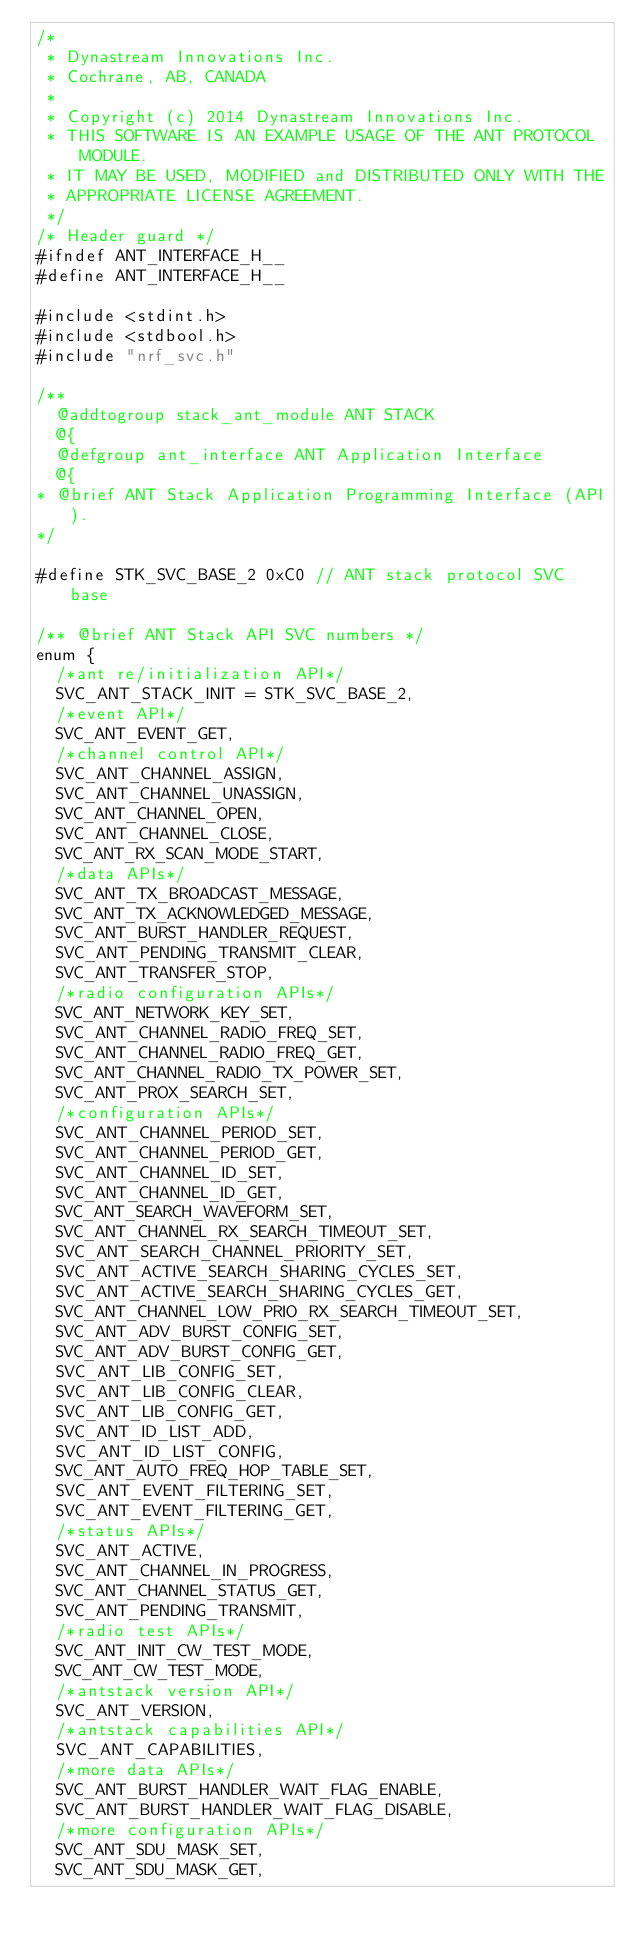Convert code to text. <code><loc_0><loc_0><loc_500><loc_500><_C_>/*
 * Dynastream Innovations Inc.
 * Cochrane, AB, CANADA
 *
 * Copyright (c) 2014 Dynastream Innovations Inc.
 * THIS SOFTWARE IS AN EXAMPLE USAGE OF THE ANT PROTOCOL MODULE.
 * IT MAY BE USED, MODIFIED and DISTRIBUTED ONLY WITH THE
 * APPROPRIATE LICENSE AGREEMENT.
 */
/* Header guard */
#ifndef ANT_INTERFACE_H__
#define ANT_INTERFACE_H__

#include <stdint.h>
#include <stdbool.h>
#include "nrf_svc.h"

/**
  @addtogroup stack_ant_module ANT STACK
  @{
  @defgroup ant_interface ANT Application Interface
  @{
* @brief ANT Stack Application Programming Interface (API).
*/

#define STK_SVC_BASE_2 0xC0 // ANT stack protocol SVC base

/** @brief ANT Stack API SVC numbers */
enum {
  /*ant re/initialization API*/
  SVC_ANT_STACK_INIT = STK_SVC_BASE_2,
  /*event API*/
  SVC_ANT_EVENT_GET,
  /*channel control API*/
  SVC_ANT_CHANNEL_ASSIGN,
  SVC_ANT_CHANNEL_UNASSIGN,
  SVC_ANT_CHANNEL_OPEN,
  SVC_ANT_CHANNEL_CLOSE,
  SVC_ANT_RX_SCAN_MODE_START,
  /*data APIs*/
  SVC_ANT_TX_BROADCAST_MESSAGE,
  SVC_ANT_TX_ACKNOWLEDGED_MESSAGE,
  SVC_ANT_BURST_HANDLER_REQUEST,
  SVC_ANT_PENDING_TRANSMIT_CLEAR,
  SVC_ANT_TRANSFER_STOP,
  /*radio configuration APIs*/
  SVC_ANT_NETWORK_KEY_SET,
  SVC_ANT_CHANNEL_RADIO_FREQ_SET,
  SVC_ANT_CHANNEL_RADIO_FREQ_GET,
  SVC_ANT_CHANNEL_RADIO_TX_POWER_SET,
  SVC_ANT_PROX_SEARCH_SET,
  /*configuration APIs*/
  SVC_ANT_CHANNEL_PERIOD_SET,
  SVC_ANT_CHANNEL_PERIOD_GET,
  SVC_ANT_CHANNEL_ID_SET,
  SVC_ANT_CHANNEL_ID_GET,
  SVC_ANT_SEARCH_WAVEFORM_SET,
  SVC_ANT_CHANNEL_RX_SEARCH_TIMEOUT_SET,
  SVC_ANT_SEARCH_CHANNEL_PRIORITY_SET,
  SVC_ANT_ACTIVE_SEARCH_SHARING_CYCLES_SET,
  SVC_ANT_ACTIVE_SEARCH_SHARING_CYCLES_GET,
  SVC_ANT_CHANNEL_LOW_PRIO_RX_SEARCH_TIMEOUT_SET,
  SVC_ANT_ADV_BURST_CONFIG_SET,
  SVC_ANT_ADV_BURST_CONFIG_GET,
  SVC_ANT_LIB_CONFIG_SET,
  SVC_ANT_LIB_CONFIG_CLEAR,
  SVC_ANT_LIB_CONFIG_GET,
  SVC_ANT_ID_LIST_ADD,
  SVC_ANT_ID_LIST_CONFIG,
  SVC_ANT_AUTO_FREQ_HOP_TABLE_SET,
  SVC_ANT_EVENT_FILTERING_SET,
  SVC_ANT_EVENT_FILTERING_GET,
  /*status APIs*/
  SVC_ANT_ACTIVE,
  SVC_ANT_CHANNEL_IN_PROGRESS,
  SVC_ANT_CHANNEL_STATUS_GET,
  SVC_ANT_PENDING_TRANSMIT,
  /*radio test APIs*/
  SVC_ANT_INIT_CW_TEST_MODE,
  SVC_ANT_CW_TEST_MODE,
  /*antstack version API*/
  SVC_ANT_VERSION,
  /*antstack capabilities API*/
  SVC_ANT_CAPABILITIES,
  /*more data APIs*/
  SVC_ANT_BURST_HANDLER_WAIT_FLAG_ENABLE,
  SVC_ANT_BURST_HANDLER_WAIT_FLAG_DISABLE,
  /*more configuration APIs*/
  SVC_ANT_SDU_MASK_SET,
  SVC_ANT_SDU_MASK_GET,</code> 